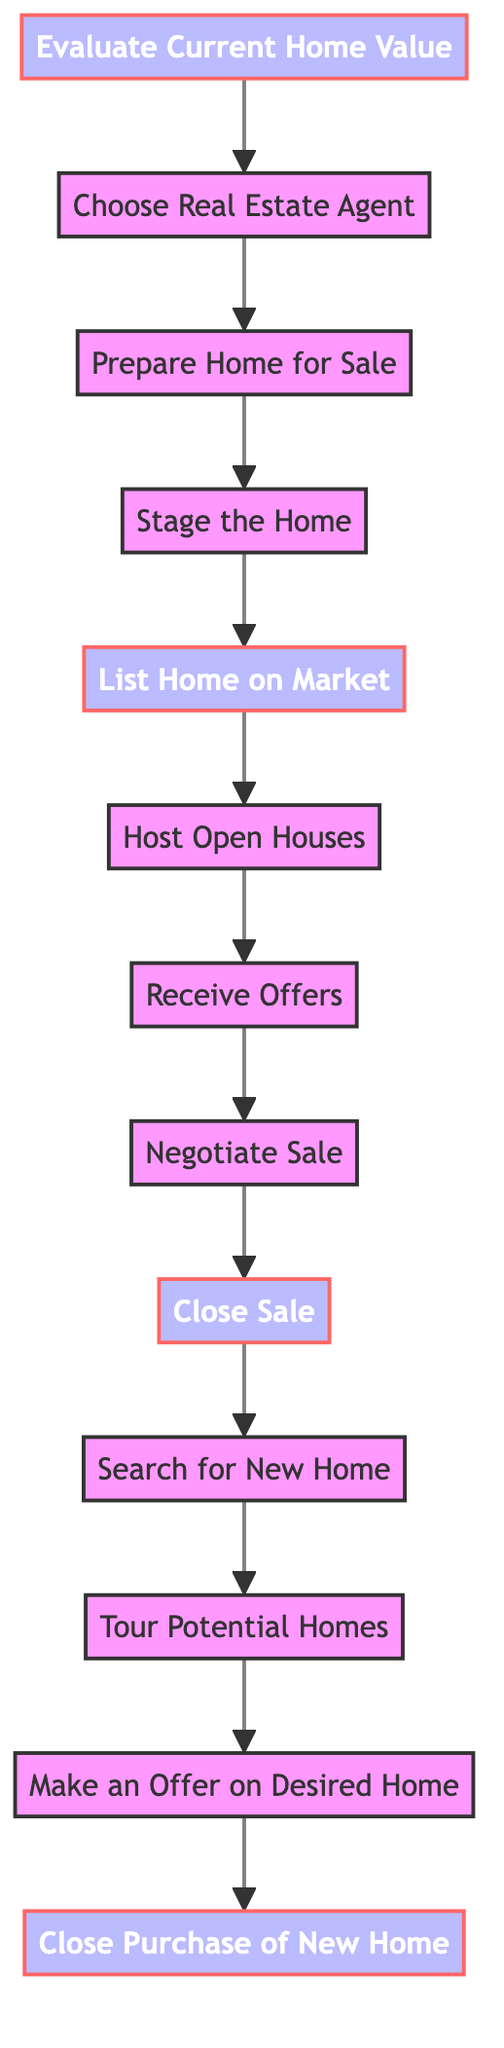What is the first step in the process? The first step is "Evaluate Current Home Value" as indicated in the diagram.
Answer: Evaluate Current Home Value How many steps are there in the process? By counting each listed step in the diagram, there are 13 total steps represented.
Answer: 13 What do you do after "Choose Real Estate Agent"? The next step after choosing an agent is "Prepare Home for Sale". This direct progression can be followed in the diagram.
Answer: Prepare Home for Sale Which step involves decluttering and cleaning? The step that focuses on decluttering and cleaning is "Prepare Home for Sale". This is explicitly mentioned in the description for that step.
Answer: Prepare Home for Sale What is the last step before closing the purchase of the new home? The last step before finalizing the purchase is "Make an Offer on Desired Home", which comes right before closing the purchase in the flow.
Answer: Make an Offer on Desired Home Is "Stage the Home" a terminal step in the process? No, "Stage the Home" is not a terminal step; it flows into the next step, which is "List Home on Market" as shown in the connections of the diagram.
Answer: No How many steps involve hosting or conducting events? There is one step that involves hosting events: "Host Open Houses". This is the only step dedicated to conducting an event for potential buyers.
Answer: 1 What are the first four steps in sequence? The first four steps in the process are: "Evaluate Current Home Value," "Choose Real Estate Agent," "Prepare Home for Sale," and "Stage the Home." These sequentially flow from one to another in the diagram.
Answer: Evaluate Current Home Value, Choose Real Estate Agent, Prepare Home for Sale, Stage the Home What is the outcome of "Close Sale"? The outcome of "Close Sale" is the finalization of ownership transfer to the buyer, as described in that step.
Answer: Finalize the sale and transfer ownership to the buyer 